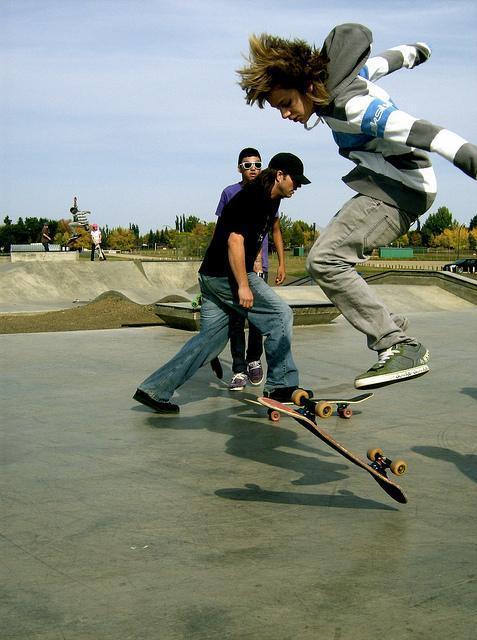How many skateboards are there?
Give a very brief answer. 3. How many skateboards do you see?
Give a very brief answer. 2. How many feet does the skateboard have touching the skateboard?
Give a very brief answer. 0. How many people are in the picture?
Give a very brief answer. 2. 